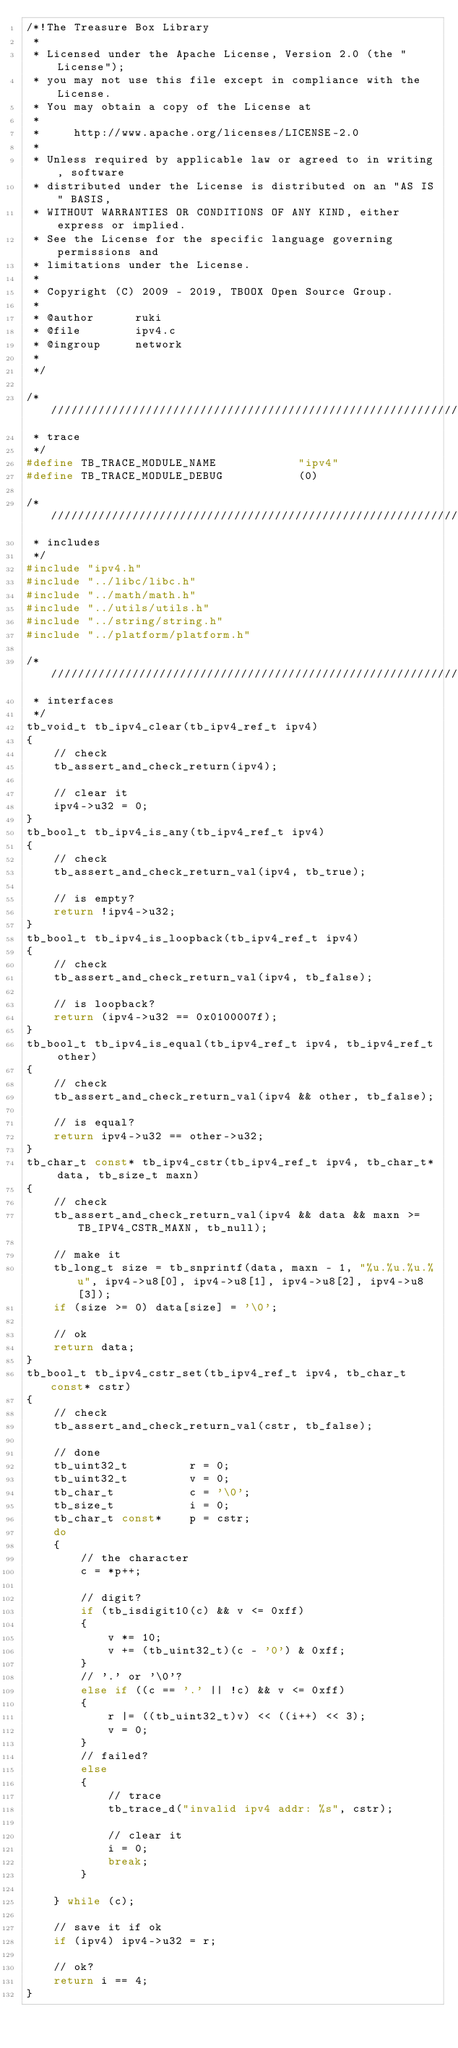Convert code to text. <code><loc_0><loc_0><loc_500><loc_500><_C_>/*!The Treasure Box Library
 *
 * Licensed under the Apache License, Version 2.0 (the "License");
 * you may not use this file except in compliance with the License.
 * You may obtain a copy of the License at
 *
 *     http://www.apache.org/licenses/LICENSE-2.0
 *
 * Unless required by applicable law or agreed to in writing, software
 * distributed under the License is distributed on an "AS IS" BASIS,
 * WITHOUT WARRANTIES OR CONDITIONS OF ANY KIND, either express or implied.
 * See the License for the specific language governing permissions and
 * limitations under the License.
 * 
 * Copyright (C) 2009 - 2019, TBOOX Open Source Group.
 *
 * @author      ruki
 * @file        ipv4.c 
 * @ingroup     network
 *
 */

/* //////////////////////////////////////////////////////////////////////////////////////
 * trace
 */
#define TB_TRACE_MODULE_NAME            "ipv4"
#define TB_TRACE_MODULE_DEBUG           (0)

/* //////////////////////////////////////////////////////////////////////////////////////
 * includes
 */
#include "ipv4.h"
#include "../libc/libc.h"
#include "../math/math.h"
#include "../utils/utils.h"
#include "../string/string.h"
#include "../platform/platform.h"

/* //////////////////////////////////////////////////////////////////////////////////////
 * interfaces
 */
tb_void_t tb_ipv4_clear(tb_ipv4_ref_t ipv4)
{
    // check
    tb_assert_and_check_return(ipv4);

    // clear it
    ipv4->u32 = 0;
}
tb_bool_t tb_ipv4_is_any(tb_ipv4_ref_t ipv4)
{
    // check
    tb_assert_and_check_return_val(ipv4, tb_true);

    // is empty?
    return !ipv4->u32;
}
tb_bool_t tb_ipv4_is_loopback(tb_ipv4_ref_t ipv4)
{
    // check
    tb_assert_and_check_return_val(ipv4, tb_false);

    // is loopback?
    return (ipv4->u32 == 0x0100007f);
}
tb_bool_t tb_ipv4_is_equal(tb_ipv4_ref_t ipv4, tb_ipv4_ref_t other)
{
    // check
    tb_assert_and_check_return_val(ipv4 && other, tb_false);

    // is equal?
    return ipv4->u32 == other->u32;
}
tb_char_t const* tb_ipv4_cstr(tb_ipv4_ref_t ipv4, tb_char_t* data, tb_size_t maxn)
{
    // check
    tb_assert_and_check_return_val(ipv4 && data && maxn >= TB_IPV4_CSTR_MAXN, tb_null);

    // make it
    tb_long_t size = tb_snprintf(data, maxn - 1, "%u.%u.%u.%u", ipv4->u8[0], ipv4->u8[1], ipv4->u8[2], ipv4->u8[3]);
    if (size >= 0) data[size] = '\0';

    // ok
    return data;
}
tb_bool_t tb_ipv4_cstr_set(tb_ipv4_ref_t ipv4, tb_char_t const* cstr)
{
    // check
    tb_assert_and_check_return_val(cstr, tb_false);

    // done
    tb_uint32_t         r = 0;
    tb_uint32_t         v = 0;
    tb_char_t           c = '\0';
    tb_size_t           i = 0;
    tb_char_t const*    p = cstr;
    do
    {
        // the character
        c = *p++;

        // digit?
        if (tb_isdigit10(c) && v <= 0xff)
        {
            v *= 10;
            v += (tb_uint32_t)(c - '0') & 0xff;
        }
        // '.' or '\0'?
        else if ((c == '.' || !c) && v <= 0xff)
        {
            r |= ((tb_uint32_t)v) << ((i++) << 3);
            v = 0;
        }
        // failed?
        else 
        {
            // trace
            tb_trace_d("invalid ipv4 addr: %s", cstr);

            // clear it
            i = 0;
            break;
        }

    } while (c);

    // save it if ok
    if (ipv4) ipv4->u32 = r;

    // ok?
    return i == 4;
}
</code> 